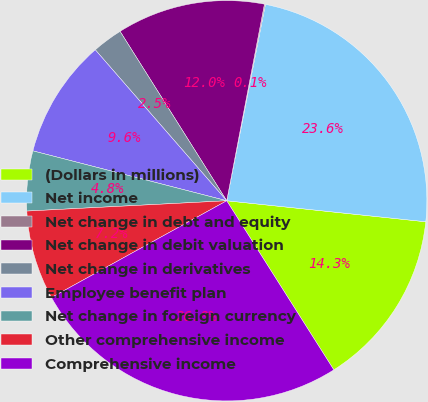Convert chart to OTSL. <chart><loc_0><loc_0><loc_500><loc_500><pie_chart><fcel>(Dollars in millions)<fcel>Net income<fcel>Net change in debt and equity<fcel>Net change in debit valuation<fcel>Net change in derivatives<fcel>Employee benefit plan<fcel>Net change in foreign currency<fcel>Other comprehensive income<fcel>Comprehensive income<nl><fcel>14.34%<fcel>23.58%<fcel>0.08%<fcel>11.96%<fcel>2.46%<fcel>9.59%<fcel>4.83%<fcel>7.21%<fcel>25.96%<nl></chart> 